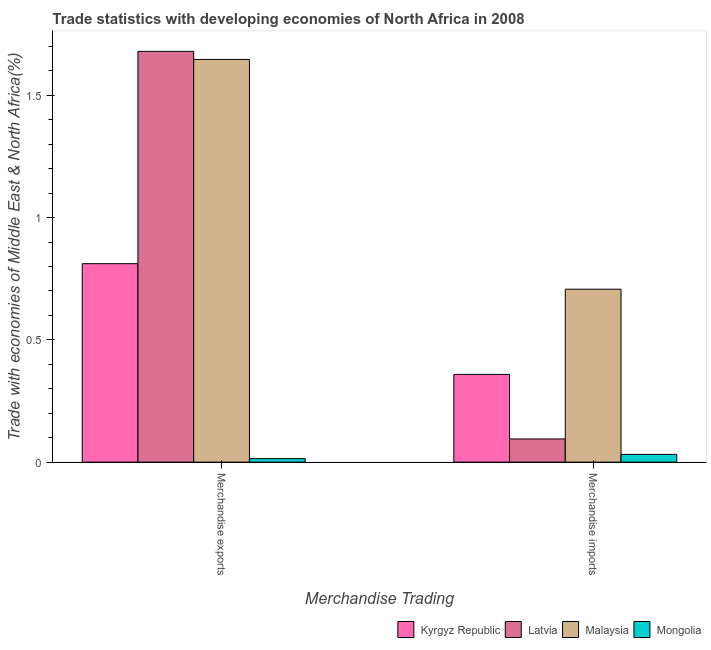How many groups of bars are there?
Provide a succinct answer. 2. What is the label of the 2nd group of bars from the left?
Your answer should be very brief. Merchandise imports. What is the merchandise imports in Latvia?
Ensure brevity in your answer.  0.09. Across all countries, what is the maximum merchandise imports?
Ensure brevity in your answer.  0.71. Across all countries, what is the minimum merchandise imports?
Make the answer very short. 0.03. In which country was the merchandise imports maximum?
Offer a terse response. Malaysia. In which country was the merchandise imports minimum?
Keep it short and to the point. Mongolia. What is the total merchandise imports in the graph?
Your answer should be very brief. 1.19. What is the difference between the merchandise imports in Latvia and that in Kyrgyz Republic?
Provide a short and direct response. -0.26. What is the difference between the merchandise exports in Latvia and the merchandise imports in Kyrgyz Republic?
Ensure brevity in your answer.  1.32. What is the average merchandise imports per country?
Give a very brief answer. 0.3. What is the difference between the merchandise exports and merchandise imports in Kyrgyz Republic?
Offer a very short reply. 0.45. In how many countries, is the merchandise exports greater than 1.6 %?
Ensure brevity in your answer.  2. What is the ratio of the merchandise imports in Latvia to that in Kyrgyz Republic?
Ensure brevity in your answer.  0.26. In how many countries, is the merchandise imports greater than the average merchandise imports taken over all countries?
Keep it short and to the point. 2. What does the 4th bar from the left in Merchandise imports represents?
Your response must be concise. Mongolia. What does the 3rd bar from the right in Merchandise exports represents?
Offer a terse response. Latvia. Are all the bars in the graph horizontal?
Your response must be concise. No. What is the difference between two consecutive major ticks on the Y-axis?
Your response must be concise. 0.5. Does the graph contain grids?
Your answer should be very brief. No. What is the title of the graph?
Your answer should be compact. Trade statistics with developing economies of North Africa in 2008. Does "Chile" appear as one of the legend labels in the graph?
Keep it short and to the point. No. What is the label or title of the X-axis?
Make the answer very short. Merchandise Trading. What is the label or title of the Y-axis?
Offer a terse response. Trade with economies of Middle East & North Africa(%). What is the Trade with economies of Middle East & North Africa(%) of Kyrgyz Republic in Merchandise exports?
Provide a short and direct response. 0.81. What is the Trade with economies of Middle East & North Africa(%) of Latvia in Merchandise exports?
Your answer should be compact. 1.68. What is the Trade with economies of Middle East & North Africa(%) in Malaysia in Merchandise exports?
Keep it short and to the point. 1.65. What is the Trade with economies of Middle East & North Africa(%) in Mongolia in Merchandise exports?
Your answer should be very brief. 0.01. What is the Trade with economies of Middle East & North Africa(%) in Kyrgyz Republic in Merchandise imports?
Offer a terse response. 0.36. What is the Trade with economies of Middle East & North Africa(%) in Latvia in Merchandise imports?
Offer a terse response. 0.09. What is the Trade with economies of Middle East & North Africa(%) in Malaysia in Merchandise imports?
Offer a terse response. 0.71. What is the Trade with economies of Middle East & North Africa(%) of Mongolia in Merchandise imports?
Your answer should be very brief. 0.03. Across all Merchandise Trading, what is the maximum Trade with economies of Middle East & North Africa(%) of Kyrgyz Republic?
Offer a very short reply. 0.81. Across all Merchandise Trading, what is the maximum Trade with economies of Middle East & North Africa(%) of Latvia?
Give a very brief answer. 1.68. Across all Merchandise Trading, what is the maximum Trade with economies of Middle East & North Africa(%) of Malaysia?
Offer a very short reply. 1.65. Across all Merchandise Trading, what is the maximum Trade with economies of Middle East & North Africa(%) of Mongolia?
Your answer should be very brief. 0.03. Across all Merchandise Trading, what is the minimum Trade with economies of Middle East & North Africa(%) of Kyrgyz Republic?
Your response must be concise. 0.36. Across all Merchandise Trading, what is the minimum Trade with economies of Middle East & North Africa(%) in Latvia?
Make the answer very short. 0.09. Across all Merchandise Trading, what is the minimum Trade with economies of Middle East & North Africa(%) of Malaysia?
Offer a terse response. 0.71. Across all Merchandise Trading, what is the minimum Trade with economies of Middle East & North Africa(%) of Mongolia?
Your answer should be compact. 0.01. What is the total Trade with economies of Middle East & North Africa(%) of Kyrgyz Republic in the graph?
Your answer should be compact. 1.17. What is the total Trade with economies of Middle East & North Africa(%) of Latvia in the graph?
Your answer should be very brief. 1.77. What is the total Trade with economies of Middle East & North Africa(%) of Malaysia in the graph?
Provide a succinct answer. 2.35. What is the total Trade with economies of Middle East & North Africa(%) of Mongolia in the graph?
Ensure brevity in your answer.  0.05. What is the difference between the Trade with economies of Middle East & North Africa(%) in Kyrgyz Republic in Merchandise exports and that in Merchandise imports?
Offer a terse response. 0.45. What is the difference between the Trade with economies of Middle East & North Africa(%) in Latvia in Merchandise exports and that in Merchandise imports?
Provide a short and direct response. 1.59. What is the difference between the Trade with economies of Middle East & North Africa(%) of Malaysia in Merchandise exports and that in Merchandise imports?
Make the answer very short. 0.94. What is the difference between the Trade with economies of Middle East & North Africa(%) in Mongolia in Merchandise exports and that in Merchandise imports?
Your answer should be compact. -0.02. What is the difference between the Trade with economies of Middle East & North Africa(%) of Kyrgyz Republic in Merchandise exports and the Trade with economies of Middle East & North Africa(%) of Latvia in Merchandise imports?
Offer a terse response. 0.72. What is the difference between the Trade with economies of Middle East & North Africa(%) in Kyrgyz Republic in Merchandise exports and the Trade with economies of Middle East & North Africa(%) in Malaysia in Merchandise imports?
Your response must be concise. 0.1. What is the difference between the Trade with economies of Middle East & North Africa(%) in Kyrgyz Republic in Merchandise exports and the Trade with economies of Middle East & North Africa(%) in Mongolia in Merchandise imports?
Your answer should be compact. 0.78. What is the difference between the Trade with economies of Middle East & North Africa(%) of Latvia in Merchandise exports and the Trade with economies of Middle East & North Africa(%) of Malaysia in Merchandise imports?
Offer a terse response. 0.97. What is the difference between the Trade with economies of Middle East & North Africa(%) in Latvia in Merchandise exports and the Trade with economies of Middle East & North Africa(%) in Mongolia in Merchandise imports?
Provide a succinct answer. 1.65. What is the difference between the Trade with economies of Middle East & North Africa(%) in Malaysia in Merchandise exports and the Trade with economies of Middle East & North Africa(%) in Mongolia in Merchandise imports?
Your answer should be compact. 1.62. What is the average Trade with economies of Middle East & North Africa(%) in Kyrgyz Republic per Merchandise Trading?
Offer a terse response. 0.59. What is the average Trade with economies of Middle East & North Africa(%) of Latvia per Merchandise Trading?
Your answer should be compact. 0.89. What is the average Trade with economies of Middle East & North Africa(%) in Malaysia per Merchandise Trading?
Make the answer very short. 1.18. What is the average Trade with economies of Middle East & North Africa(%) of Mongolia per Merchandise Trading?
Offer a terse response. 0.02. What is the difference between the Trade with economies of Middle East & North Africa(%) in Kyrgyz Republic and Trade with economies of Middle East & North Africa(%) in Latvia in Merchandise exports?
Provide a short and direct response. -0.87. What is the difference between the Trade with economies of Middle East & North Africa(%) in Kyrgyz Republic and Trade with economies of Middle East & North Africa(%) in Malaysia in Merchandise exports?
Make the answer very short. -0.84. What is the difference between the Trade with economies of Middle East & North Africa(%) in Kyrgyz Republic and Trade with economies of Middle East & North Africa(%) in Mongolia in Merchandise exports?
Your response must be concise. 0.8. What is the difference between the Trade with economies of Middle East & North Africa(%) in Latvia and Trade with economies of Middle East & North Africa(%) in Malaysia in Merchandise exports?
Your response must be concise. 0.03. What is the difference between the Trade with economies of Middle East & North Africa(%) of Latvia and Trade with economies of Middle East & North Africa(%) of Mongolia in Merchandise exports?
Make the answer very short. 1.67. What is the difference between the Trade with economies of Middle East & North Africa(%) of Malaysia and Trade with economies of Middle East & North Africa(%) of Mongolia in Merchandise exports?
Your answer should be very brief. 1.63. What is the difference between the Trade with economies of Middle East & North Africa(%) in Kyrgyz Republic and Trade with economies of Middle East & North Africa(%) in Latvia in Merchandise imports?
Keep it short and to the point. 0.26. What is the difference between the Trade with economies of Middle East & North Africa(%) of Kyrgyz Republic and Trade with economies of Middle East & North Africa(%) of Malaysia in Merchandise imports?
Keep it short and to the point. -0.35. What is the difference between the Trade with economies of Middle East & North Africa(%) in Kyrgyz Republic and Trade with economies of Middle East & North Africa(%) in Mongolia in Merchandise imports?
Your response must be concise. 0.33. What is the difference between the Trade with economies of Middle East & North Africa(%) of Latvia and Trade with economies of Middle East & North Africa(%) of Malaysia in Merchandise imports?
Give a very brief answer. -0.61. What is the difference between the Trade with economies of Middle East & North Africa(%) of Latvia and Trade with economies of Middle East & North Africa(%) of Mongolia in Merchandise imports?
Provide a succinct answer. 0.06. What is the difference between the Trade with economies of Middle East & North Africa(%) in Malaysia and Trade with economies of Middle East & North Africa(%) in Mongolia in Merchandise imports?
Your answer should be very brief. 0.68. What is the ratio of the Trade with economies of Middle East & North Africa(%) in Kyrgyz Republic in Merchandise exports to that in Merchandise imports?
Provide a succinct answer. 2.26. What is the ratio of the Trade with economies of Middle East & North Africa(%) of Latvia in Merchandise exports to that in Merchandise imports?
Offer a terse response. 17.72. What is the ratio of the Trade with economies of Middle East & North Africa(%) in Malaysia in Merchandise exports to that in Merchandise imports?
Your response must be concise. 2.33. What is the ratio of the Trade with economies of Middle East & North Africa(%) in Mongolia in Merchandise exports to that in Merchandise imports?
Your answer should be compact. 0.45. What is the difference between the highest and the second highest Trade with economies of Middle East & North Africa(%) of Kyrgyz Republic?
Keep it short and to the point. 0.45. What is the difference between the highest and the second highest Trade with economies of Middle East & North Africa(%) of Latvia?
Provide a succinct answer. 1.59. What is the difference between the highest and the second highest Trade with economies of Middle East & North Africa(%) of Malaysia?
Make the answer very short. 0.94. What is the difference between the highest and the second highest Trade with economies of Middle East & North Africa(%) in Mongolia?
Your response must be concise. 0.02. What is the difference between the highest and the lowest Trade with economies of Middle East & North Africa(%) of Kyrgyz Republic?
Your response must be concise. 0.45. What is the difference between the highest and the lowest Trade with economies of Middle East & North Africa(%) of Latvia?
Provide a succinct answer. 1.59. What is the difference between the highest and the lowest Trade with economies of Middle East & North Africa(%) of Malaysia?
Keep it short and to the point. 0.94. What is the difference between the highest and the lowest Trade with economies of Middle East & North Africa(%) in Mongolia?
Provide a short and direct response. 0.02. 